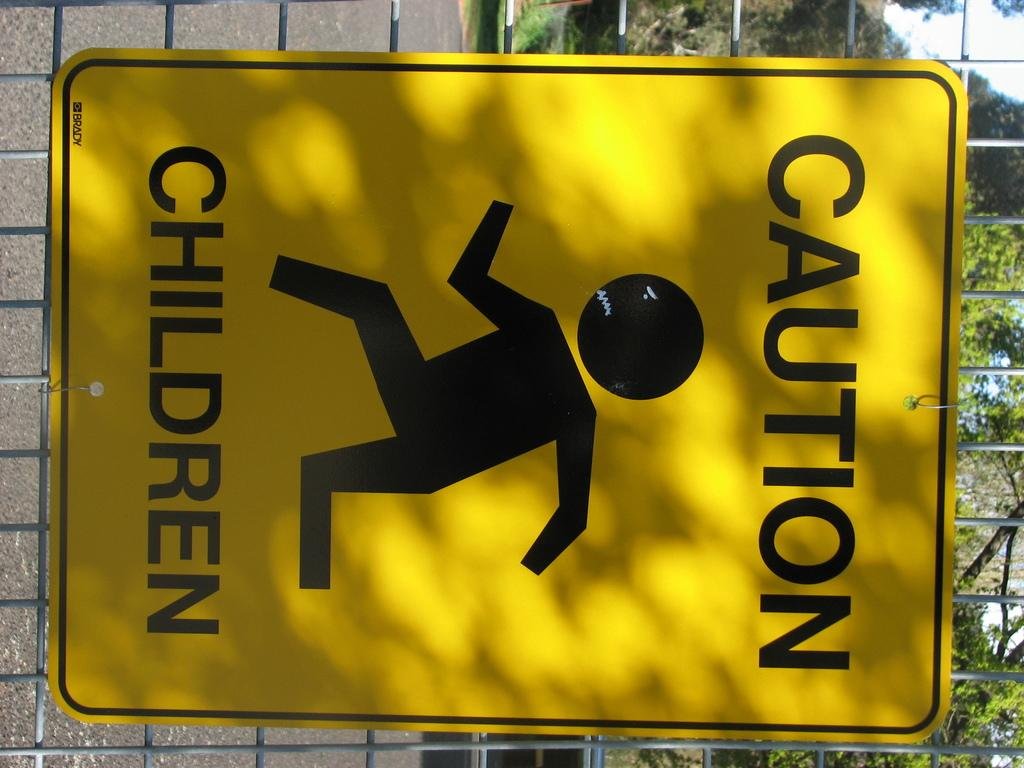What is on the fencing in the foreground of the picture? There is a board on the fencing in the foreground of the picture. What can be seen in the background of the picture? There are trees and a wall in the background of the picture. What type of whip is being used to hit the table in the image? There is no table or whip present in the image. 